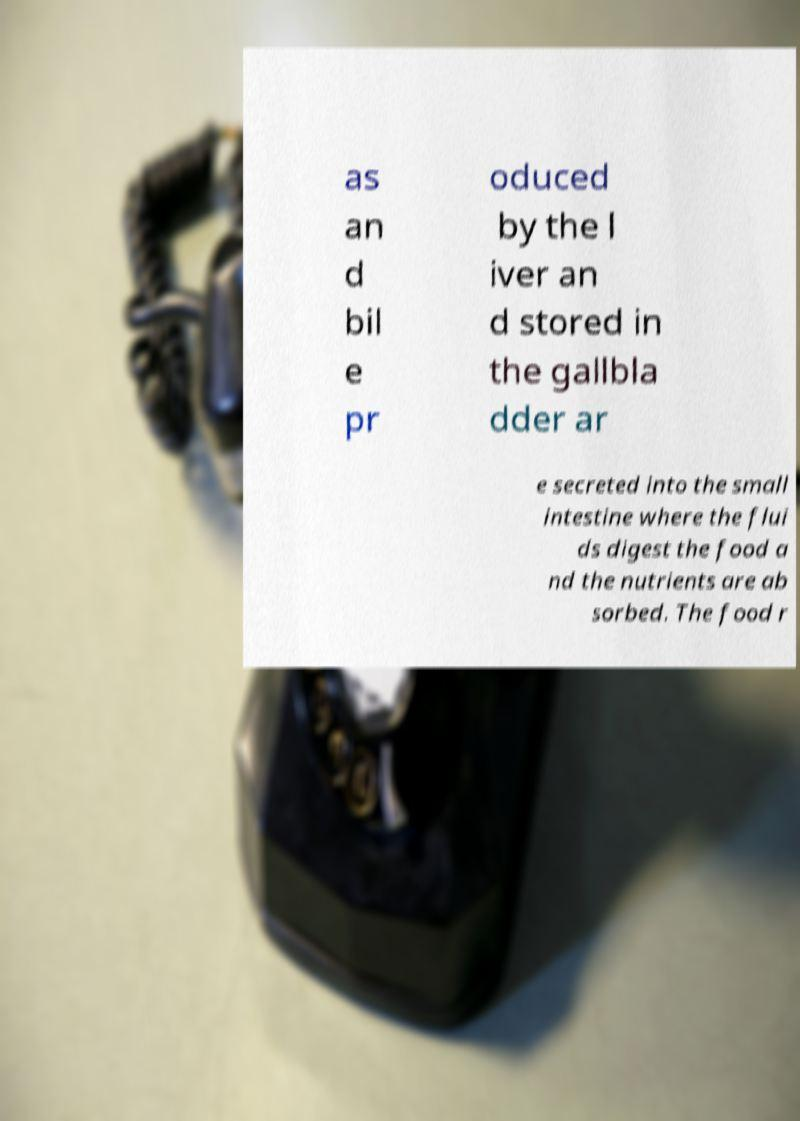Please identify and transcribe the text found in this image. as an d bil e pr oduced by the l iver an d stored in the gallbla dder ar e secreted into the small intestine where the flui ds digest the food a nd the nutrients are ab sorbed. The food r 